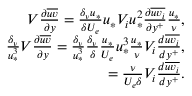<formula> <loc_0><loc_0><loc_500><loc_500>\begin{array} { r } { V \frac { \partial \overline { u v } } { \partial y } = \frac { \delta _ { \nu } u _ { * } } { \delta U _ { e } } u _ { * } V _ { i } u _ { * } ^ { 2 } \frac { \partial \overline { { u v _ { i } } } } { \partial y ^ { + } } \frac { u _ { * } } { \nu } , } \\ { \frac { \delta _ { \nu } } { u _ { * } ^ { 3 } } V \frac { \partial \overline { u v } } { \partial y } = \frac { \delta _ { \nu } } { u _ { * } ^ { 3 } } \frac { \delta _ { \nu } } { \delta } \frac { u _ { * } } { U _ { e } } u _ { * } ^ { 3 } \frac { u _ { * } } { \nu } V _ { i } \frac { d \overline { { u v _ { i } } } } { d y ^ { + } } , } \\ { = \frac { \nu } { U _ { e } \delta } V _ { i } \frac { d \overline { { u v _ { i } } } } { d y ^ { + } } . } \end{array}</formula> 